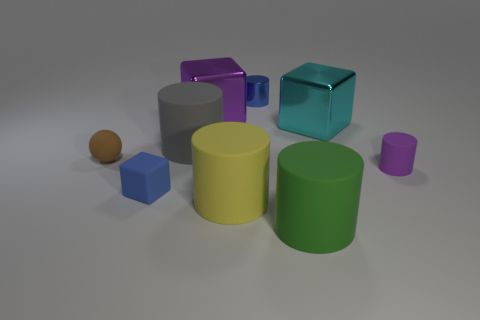Which two shapes are most similar in size and material, and what kind of light setting might this scene have? The two shapes most similar in size and material are the small purple cylinder and the blue cube. They have a similar matte finish and are small compared to the other shapes. The scene appears to be lit by a soft, diffused overhead light source, giving the objects soft shadows and highlights, which suggests an indoor setting with ambient lighting. 